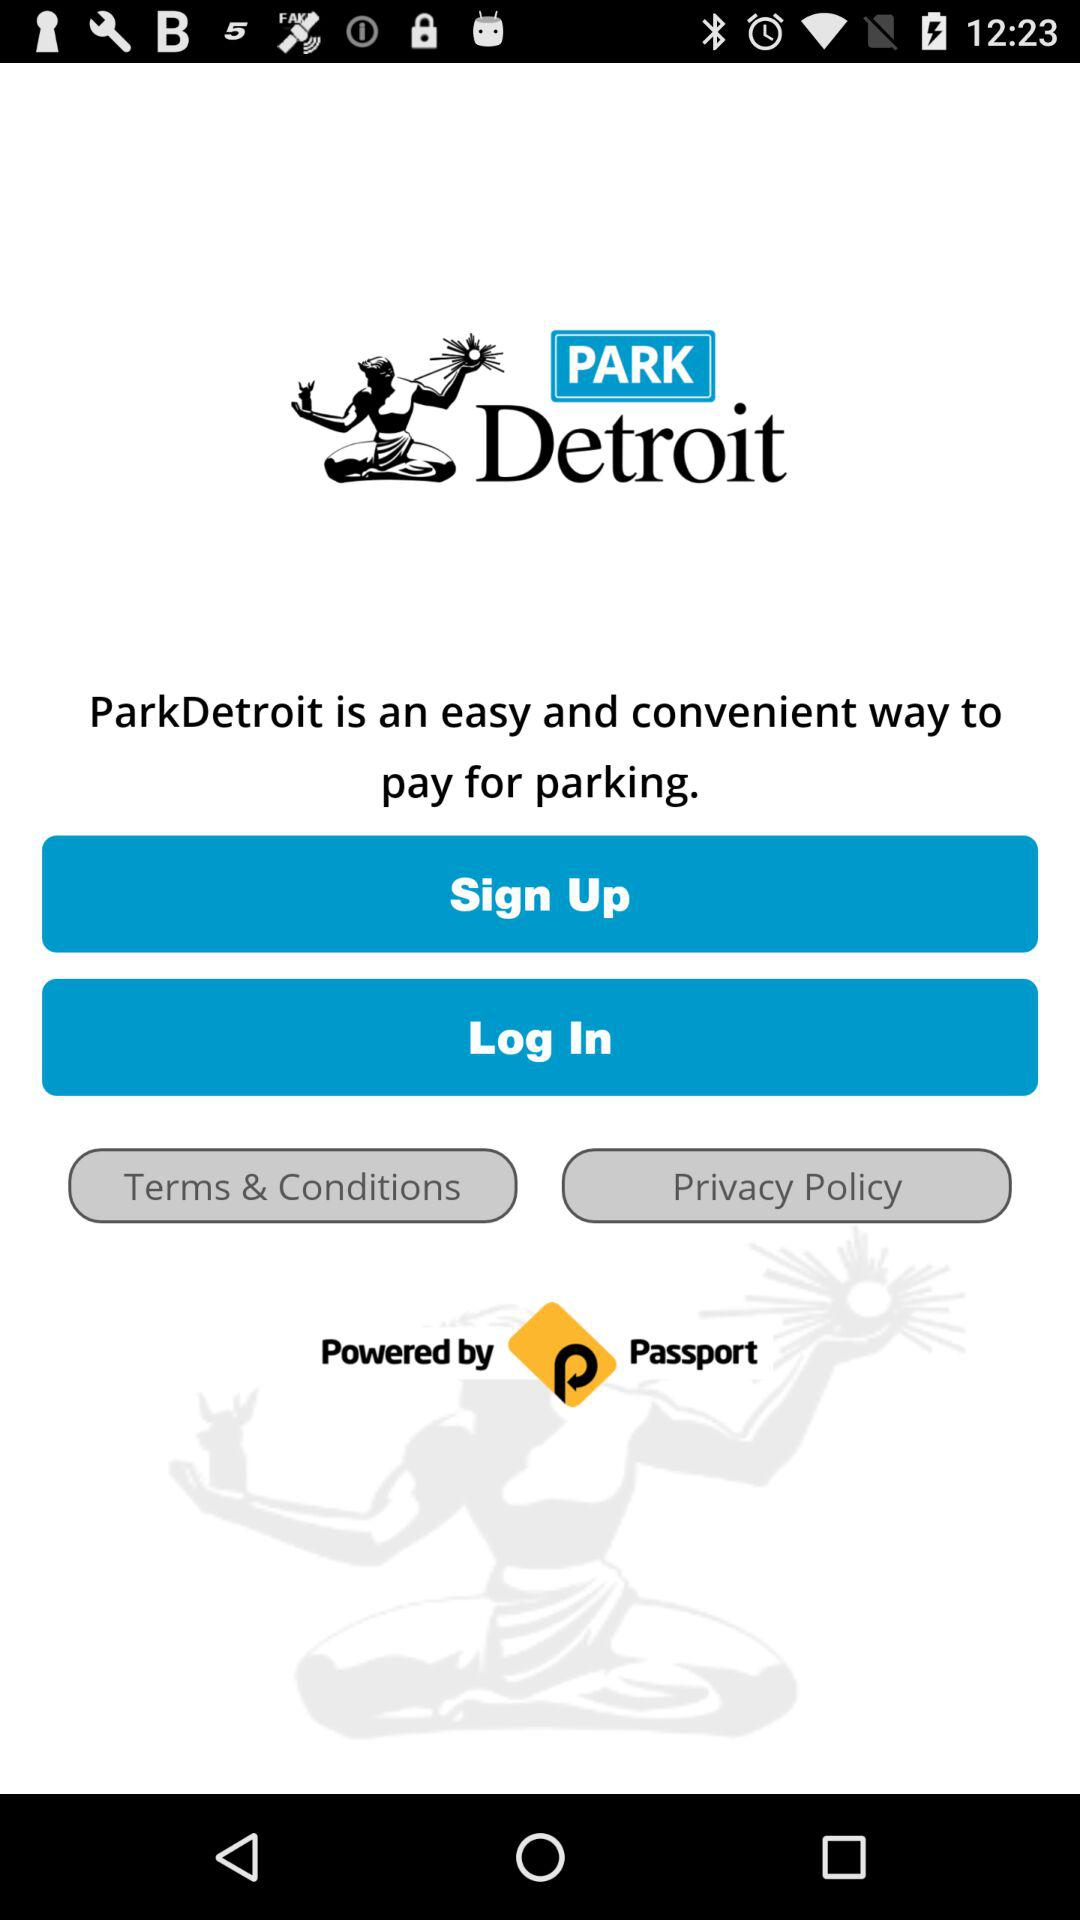What account can be used to log in? The account that can be used to log in is "ParkDetroit". 